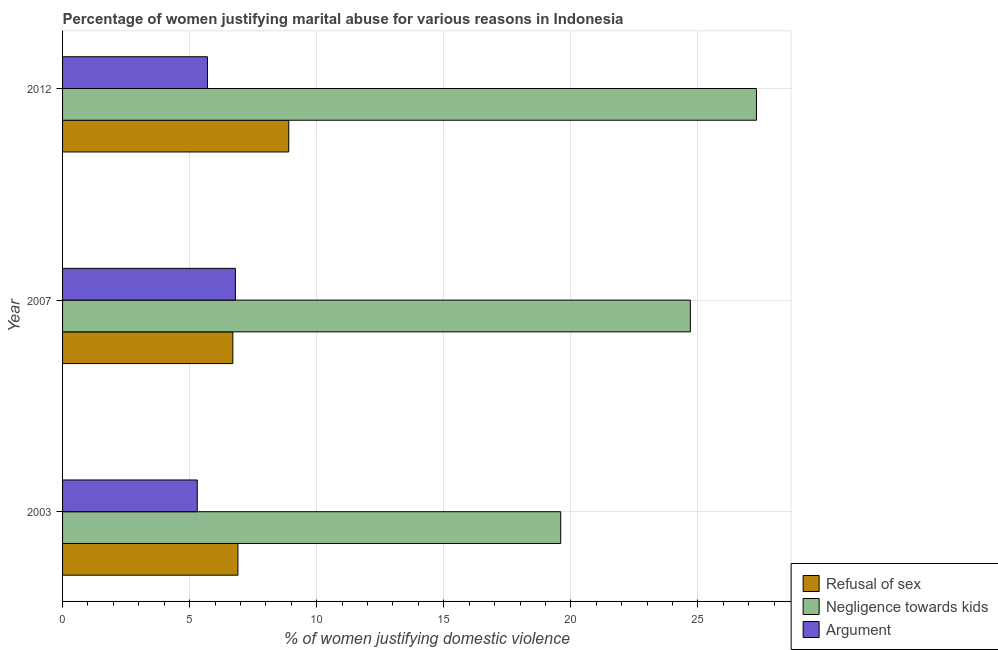How many different coloured bars are there?
Ensure brevity in your answer.  3. How many groups of bars are there?
Your answer should be compact. 3. Are the number of bars per tick equal to the number of legend labels?
Give a very brief answer. Yes. Are the number of bars on each tick of the Y-axis equal?
Give a very brief answer. Yes. How many bars are there on the 3rd tick from the top?
Ensure brevity in your answer.  3. What is the label of the 1st group of bars from the top?
Provide a succinct answer. 2012. What is the percentage of women justifying domestic violence due to arguments in 2012?
Your answer should be very brief. 5.7. Across all years, what is the minimum percentage of women justifying domestic violence due to arguments?
Provide a short and direct response. 5.3. In which year was the percentage of women justifying domestic violence due to negligence towards kids minimum?
Your response must be concise. 2003. What is the total percentage of women justifying domestic violence due to refusal of sex in the graph?
Give a very brief answer. 22.5. What is the difference between the percentage of women justifying domestic violence due to refusal of sex in 2007 and the percentage of women justifying domestic violence due to arguments in 2003?
Your response must be concise. 1.4. What is the average percentage of women justifying domestic violence due to arguments per year?
Give a very brief answer. 5.93. In the year 2003, what is the difference between the percentage of women justifying domestic violence due to arguments and percentage of women justifying domestic violence due to negligence towards kids?
Ensure brevity in your answer.  -14.3. In how many years, is the percentage of women justifying domestic violence due to refusal of sex greater than 9 %?
Keep it short and to the point. 0. What is the ratio of the percentage of women justifying domestic violence due to negligence towards kids in 2003 to that in 2012?
Offer a very short reply. 0.72. What is the difference between the highest and the second highest percentage of women justifying domestic violence due to negligence towards kids?
Your answer should be compact. 2.6. In how many years, is the percentage of women justifying domestic violence due to arguments greater than the average percentage of women justifying domestic violence due to arguments taken over all years?
Offer a very short reply. 1. What does the 3rd bar from the top in 2007 represents?
Offer a very short reply. Refusal of sex. What does the 3rd bar from the bottom in 2007 represents?
Offer a very short reply. Argument. Is it the case that in every year, the sum of the percentage of women justifying domestic violence due to refusal of sex and percentage of women justifying domestic violence due to negligence towards kids is greater than the percentage of women justifying domestic violence due to arguments?
Your response must be concise. Yes. What is the difference between two consecutive major ticks on the X-axis?
Provide a succinct answer. 5. Are the values on the major ticks of X-axis written in scientific E-notation?
Ensure brevity in your answer.  No. Does the graph contain any zero values?
Provide a short and direct response. No. How are the legend labels stacked?
Offer a very short reply. Vertical. What is the title of the graph?
Your answer should be very brief. Percentage of women justifying marital abuse for various reasons in Indonesia. What is the label or title of the X-axis?
Your response must be concise. % of women justifying domestic violence. What is the label or title of the Y-axis?
Your response must be concise. Year. What is the % of women justifying domestic violence of Refusal of sex in 2003?
Your answer should be compact. 6.9. What is the % of women justifying domestic violence of Negligence towards kids in 2003?
Ensure brevity in your answer.  19.6. What is the % of women justifying domestic violence in Refusal of sex in 2007?
Provide a succinct answer. 6.7. What is the % of women justifying domestic violence of Negligence towards kids in 2007?
Make the answer very short. 24.7. What is the % of women justifying domestic violence of Refusal of sex in 2012?
Provide a succinct answer. 8.9. What is the % of women justifying domestic violence of Negligence towards kids in 2012?
Ensure brevity in your answer.  27.3. Across all years, what is the maximum % of women justifying domestic violence of Refusal of sex?
Your answer should be compact. 8.9. Across all years, what is the maximum % of women justifying domestic violence in Negligence towards kids?
Provide a short and direct response. 27.3. Across all years, what is the minimum % of women justifying domestic violence of Refusal of sex?
Give a very brief answer. 6.7. Across all years, what is the minimum % of women justifying domestic violence in Negligence towards kids?
Offer a very short reply. 19.6. Across all years, what is the minimum % of women justifying domestic violence of Argument?
Make the answer very short. 5.3. What is the total % of women justifying domestic violence of Negligence towards kids in the graph?
Give a very brief answer. 71.6. What is the total % of women justifying domestic violence in Argument in the graph?
Keep it short and to the point. 17.8. What is the difference between the % of women justifying domestic violence of Negligence towards kids in 2003 and that in 2007?
Give a very brief answer. -5.1. What is the difference between the % of women justifying domestic violence in Refusal of sex in 2003 and that in 2012?
Your answer should be very brief. -2. What is the difference between the % of women justifying domestic violence of Argument in 2003 and that in 2012?
Provide a short and direct response. -0.4. What is the difference between the % of women justifying domestic violence of Refusal of sex in 2007 and that in 2012?
Provide a succinct answer. -2.2. What is the difference between the % of women justifying domestic violence in Negligence towards kids in 2007 and that in 2012?
Ensure brevity in your answer.  -2.6. What is the difference between the % of women justifying domestic violence in Argument in 2007 and that in 2012?
Give a very brief answer. 1.1. What is the difference between the % of women justifying domestic violence of Refusal of sex in 2003 and the % of women justifying domestic violence of Negligence towards kids in 2007?
Provide a short and direct response. -17.8. What is the difference between the % of women justifying domestic violence in Refusal of sex in 2003 and the % of women justifying domestic violence in Argument in 2007?
Offer a very short reply. 0.1. What is the difference between the % of women justifying domestic violence of Refusal of sex in 2003 and the % of women justifying domestic violence of Negligence towards kids in 2012?
Provide a succinct answer. -20.4. What is the difference between the % of women justifying domestic violence in Negligence towards kids in 2003 and the % of women justifying domestic violence in Argument in 2012?
Offer a very short reply. 13.9. What is the difference between the % of women justifying domestic violence in Refusal of sex in 2007 and the % of women justifying domestic violence in Negligence towards kids in 2012?
Your answer should be very brief. -20.6. What is the difference between the % of women justifying domestic violence of Refusal of sex in 2007 and the % of women justifying domestic violence of Argument in 2012?
Offer a terse response. 1. What is the average % of women justifying domestic violence in Refusal of sex per year?
Offer a terse response. 7.5. What is the average % of women justifying domestic violence in Negligence towards kids per year?
Your answer should be compact. 23.87. What is the average % of women justifying domestic violence of Argument per year?
Provide a succinct answer. 5.93. In the year 2003, what is the difference between the % of women justifying domestic violence of Refusal of sex and % of women justifying domestic violence of Negligence towards kids?
Keep it short and to the point. -12.7. In the year 2003, what is the difference between the % of women justifying domestic violence of Negligence towards kids and % of women justifying domestic violence of Argument?
Make the answer very short. 14.3. In the year 2007, what is the difference between the % of women justifying domestic violence of Refusal of sex and % of women justifying domestic violence of Argument?
Offer a terse response. -0.1. In the year 2007, what is the difference between the % of women justifying domestic violence in Negligence towards kids and % of women justifying domestic violence in Argument?
Provide a succinct answer. 17.9. In the year 2012, what is the difference between the % of women justifying domestic violence of Refusal of sex and % of women justifying domestic violence of Negligence towards kids?
Make the answer very short. -18.4. In the year 2012, what is the difference between the % of women justifying domestic violence in Negligence towards kids and % of women justifying domestic violence in Argument?
Provide a succinct answer. 21.6. What is the ratio of the % of women justifying domestic violence in Refusal of sex in 2003 to that in 2007?
Ensure brevity in your answer.  1.03. What is the ratio of the % of women justifying domestic violence of Negligence towards kids in 2003 to that in 2007?
Your answer should be compact. 0.79. What is the ratio of the % of women justifying domestic violence in Argument in 2003 to that in 2007?
Keep it short and to the point. 0.78. What is the ratio of the % of women justifying domestic violence of Refusal of sex in 2003 to that in 2012?
Offer a very short reply. 0.78. What is the ratio of the % of women justifying domestic violence in Negligence towards kids in 2003 to that in 2012?
Offer a very short reply. 0.72. What is the ratio of the % of women justifying domestic violence of Argument in 2003 to that in 2012?
Provide a short and direct response. 0.93. What is the ratio of the % of women justifying domestic violence in Refusal of sex in 2007 to that in 2012?
Provide a short and direct response. 0.75. What is the ratio of the % of women justifying domestic violence of Negligence towards kids in 2007 to that in 2012?
Give a very brief answer. 0.9. What is the ratio of the % of women justifying domestic violence of Argument in 2007 to that in 2012?
Give a very brief answer. 1.19. What is the difference between the highest and the lowest % of women justifying domestic violence of Refusal of sex?
Give a very brief answer. 2.2. What is the difference between the highest and the lowest % of women justifying domestic violence of Negligence towards kids?
Offer a very short reply. 7.7. 